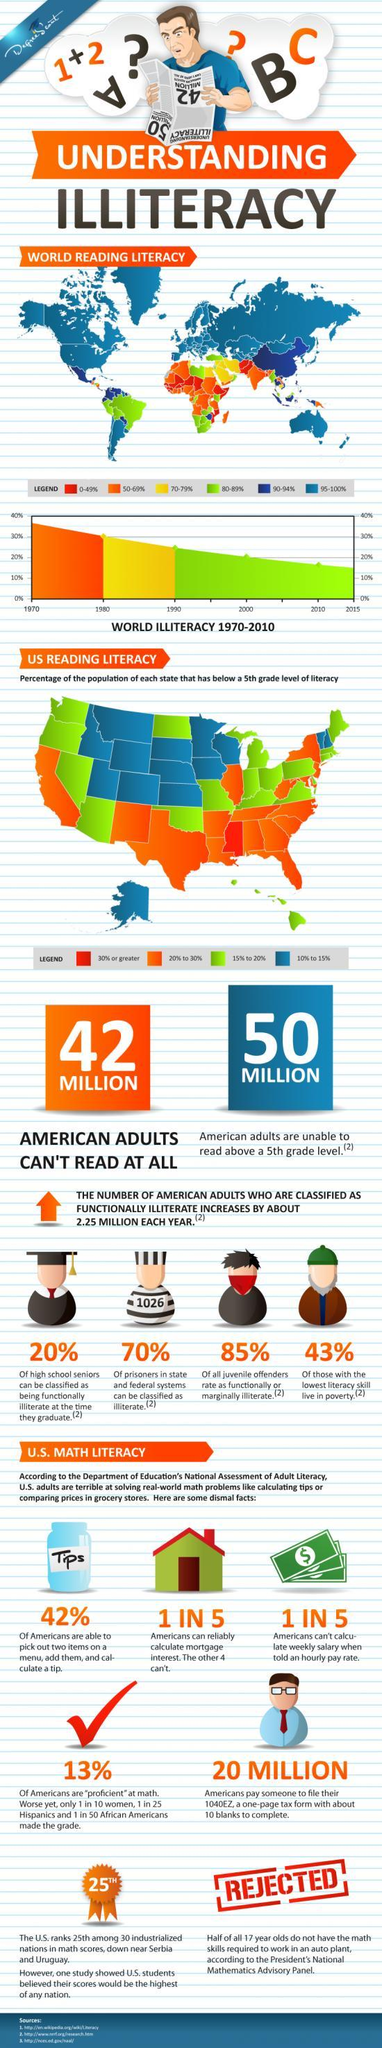What percentage of the population of Texas has below 5th grade level of literacy?
Answer the question with a short phrase. 20% to 30% What is the reading literacy rate in Canada? 95-100% What is the reading literacy rate in Australia? 95-100% What percentage of the population of Alaska has below 5th grade level of literacy? 10% to 15% What percentage of Americans are proficient at Maths? 13% What percentage of the population of Hawaii has below 5th grade level of literacy? 15% to 20% What percentage of the prisoners in state & federal systems in the U.S. can be classified as illiterate? 70% What is the reading literacy rate in India? 50-69% What is the reading literacy rate in China? 90-94% How many adults in the U.S. cannot read? 42 MILLION 